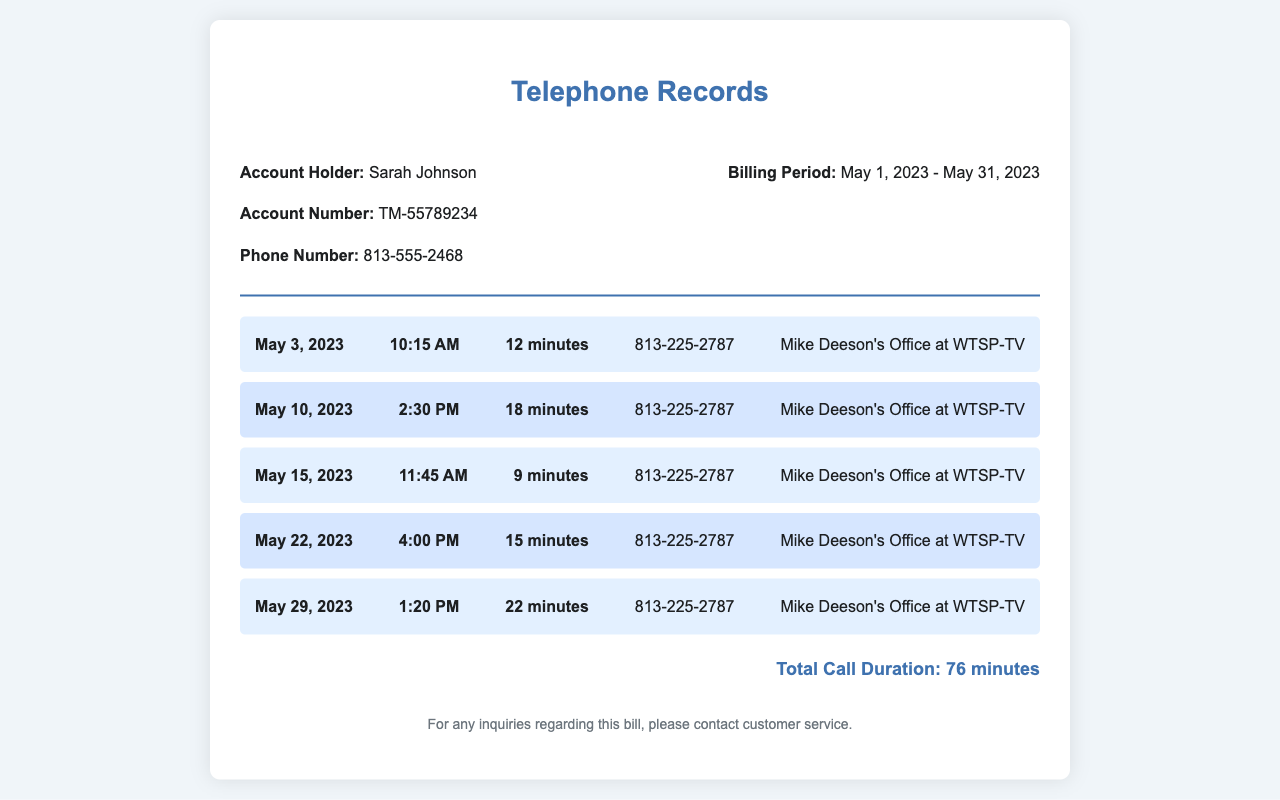What is the account holder's name? The account holder's name is clearly listed at the top of the document.
Answer: Sarah Johnson What is the account number? The document states the account number in the header section.
Answer: TM-55789234 Which phone number is listed in the records? The phone number is provided in the account details within the document.
Answer: 813-555-2468 What is the total call duration? The total call duration is calculated based on the individual call durations listed in the document.
Answer: 76 minutes How many times did Sarah Johnson call Mike Deeson's office in May 2023? The document lists a total of five calls made to the same number within the billing period.
Answer: 5 On what date did the longest call occur? The longest call duration is mentioned in the document, specifying the date of that call.
Answer: May 29, 2023 What was the duration of the call on May 10, 2023? The duration of each call is detailed alongside the date and time in the call list.
Answer: 18 minutes What is the purpose of the calls made to Mike Deeson's office? The content of the calls indicates that the purpose was to seek mentorship and career advice.
Answer: Mentorship and career advice What is the billing period mentioned in the document? The billing period is specified in a clearly labeled section within the header.
Answer: May 1, 2023 - May 31, 2023 